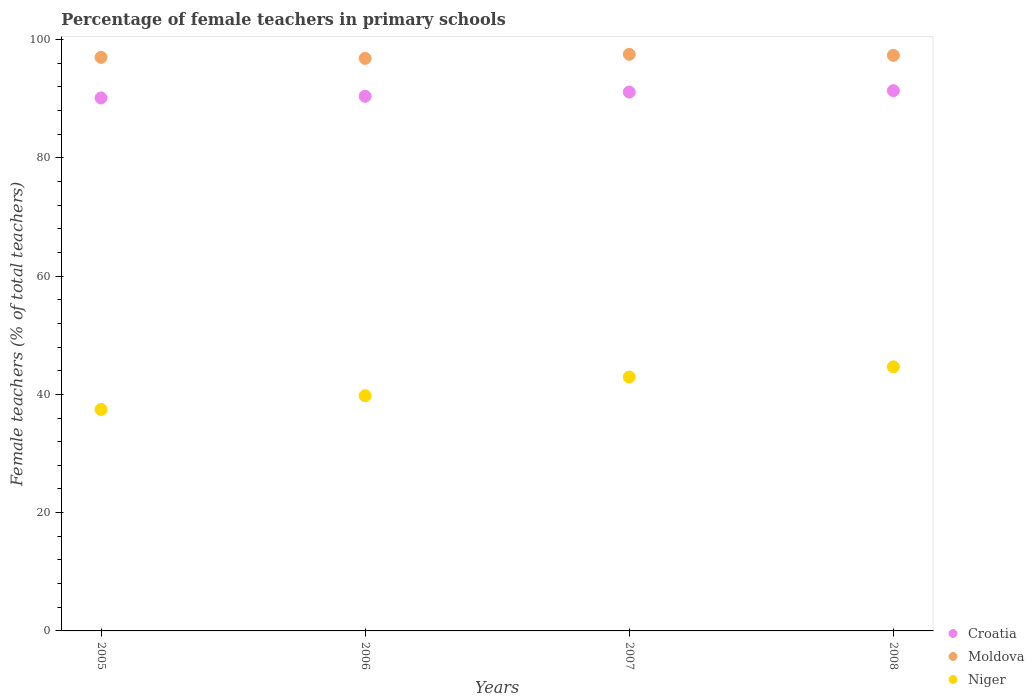Is the number of dotlines equal to the number of legend labels?
Your answer should be compact. Yes. What is the percentage of female teachers in Niger in 2007?
Ensure brevity in your answer.  42.93. Across all years, what is the maximum percentage of female teachers in Niger?
Provide a short and direct response. 44.66. Across all years, what is the minimum percentage of female teachers in Moldova?
Keep it short and to the point. 96.8. In which year was the percentage of female teachers in Moldova maximum?
Provide a succinct answer. 2007. What is the total percentage of female teachers in Niger in the graph?
Ensure brevity in your answer.  164.8. What is the difference between the percentage of female teachers in Croatia in 2006 and that in 2007?
Your answer should be very brief. -0.71. What is the difference between the percentage of female teachers in Moldova in 2006 and the percentage of female teachers in Croatia in 2005?
Your response must be concise. 6.68. What is the average percentage of female teachers in Croatia per year?
Provide a short and direct response. 90.74. In the year 2007, what is the difference between the percentage of female teachers in Moldova and percentage of female teachers in Croatia?
Provide a short and direct response. 6.38. What is the ratio of the percentage of female teachers in Niger in 2005 to that in 2006?
Give a very brief answer. 0.94. Is the percentage of female teachers in Croatia in 2005 less than that in 2006?
Ensure brevity in your answer.  Yes. What is the difference between the highest and the second highest percentage of female teachers in Niger?
Ensure brevity in your answer.  1.72. What is the difference between the highest and the lowest percentage of female teachers in Niger?
Your answer should be very brief. 7.22. In how many years, is the percentage of female teachers in Moldova greater than the average percentage of female teachers in Moldova taken over all years?
Provide a succinct answer. 2. Is the sum of the percentage of female teachers in Moldova in 2006 and 2008 greater than the maximum percentage of female teachers in Croatia across all years?
Your response must be concise. Yes. Is it the case that in every year, the sum of the percentage of female teachers in Moldova and percentage of female teachers in Niger  is greater than the percentage of female teachers in Croatia?
Ensure brevity in your answer.  Yes. Does the percentage of female teachers in Moldova monotonically increase over the years?
Ensure brevity in your answer.  No. Is the percentage of female teachers in Niger strictly greater than the percentage of female teachers in Moldova over the years?
Make the answer very short. No. How many dotlines are there?
Your response must be concise. 3. Does the graph contain any zero values?
Your answer should be very brief. No. Where does the legend appear in the graph?
Your answer should be compact. Bottom right. How are the legend labels stacked?
Your answer should be compact. Vertical. What is the title of the graph?
Offer a terse response. Percentage of female teachers in primary schools. What is the label or title of the Y-axis?
Keep it short and to the point. Female teachers (% of total teachers). What is the Female teachers (% of total teachers) of Croatia in 2005?
Make the answer very short. 90.12. What is the Female teachers (% of total teachers) in Moldova in 2005?
Offer a terse response. 96.98. What is the Female teachers (% of total teachers) in Niger in 2005?
Your answer should be compact. 37.44. What is the Female teachers (% of total teachers) in Croatia in 2006?
Provide a succinct answer. 90.4. What is the Female teachers (% of total teachers) of Moldova in 2006?
Make the answer very short. 96.8. What is the Female teachers (% of total teachers) of Niger in 2006?
Ensure brevity in your answer.  39.77. What is the Female teachers (% of total teachers) of Croatia in 2007?
Provide a succinct answer. 91.11. What is the Female teachers (% of total teachers) in Moldova in 2007?
Your answer should be very brief. 97.49. What is the Female teachers (% of total teachers) of Niger in 2007?
Keep it short and to the point. 42.93. What is the Female teachers (% of total teachers) in Croatia in 2008?
Your response must be concise. 91.35. What is the Female teachers (% of total teachers) of Moldova in 2008?
Offer a very short reply. 97.32. What is the Female teachers (% of total teachers) of Niger in 2008?
Provide a succinct answer. 44.66. Across all years, what is the maximum Female teachers (% of total teachers) in Croatia?
Give a very brief answer. 91.35. Across all years, what is the maximum Female teachers (% of total teachers) in Moldova?
Keep it short and to the point. 97.49. Across all years, what is the maximum Female teachers (% of total teachers) of Niger?
Your response must be concise. 44.66. Across all years, what is the minimum Female teachers (% of total teachers) of Croatia?
Make the answer very short. 90.12. Across all years, what is the minimum Female teachers (% of total teachers) in Moldova?
Offer a very short reply. 96.8. Across all years, what is the minimum Female teachers (% of total teachers) in Niger?
Offer a very short reply. 37.44. What is the total Female teachers (% of total teachers) in Croatia in the graph?
Offer a very short reply. 362.98. What is the total Female teachers (% of total teachers) in Moldova in the graph?
Make the answer very short. 388.59. What is the total Female teachers (% of total teachers) of Niger in the graph?
Your answer should be compact. 164.8. What is the difference between the Female teachers (% of total teachers) in Croatia in 2005 and that in 2006?
Your answer should be compact. -0.28. What is the difference between the Female teachers (% of total teachers) of Moldova in 2005 and that in 2006?
Provide a succinct answer. 0.18. What is the difference between the Female teachers (% of total teachers) of Niger in 2005 and that in 2006?
Offer a very short reply. -2.33. What is the difference between the Female teachers (% of total teachers) of Croatia in 2005 and that in 2007?
Ensure brevity in your answer.  -0.98. What is the difference between the Female teachers (% of total teachers) in Moldova in 2005 and that in 2007?
Make the answer very short. -0.51. What is the difference between the Female teachers (% of total teachers) in Niger in 2005 and that in 2007?
Ensure brevity in your answer.  -5.5. What is the difference between the Female teachers (% of total teachers) in Croatia in 2005 and that in 2008?
Your answer should be very brief. -1.22. What is the difference between the Female teachers (% of total teachers) of Moldova in 2005 and that in 2008?
Offer a very short reply. -0.35. What is the difference between the Female teachers (% of total teachers) of Niger in 2005 and that in 2008?
Keep it short and to the point. -7.22. What is the difference between the Female teachers (% of total teachers) of Croatia in 2006 and that in 2007?
Offer a very short reply. -0.71. What is the difference between the Female teachers (% of total teachers) in Moldova in 2006 and that in 2007?
Provide a succinct answer. -0.69. What is the difference between the Female teachers (% of total teachers) of Niger in 2006 and that in 2007?
Your response must be concise. -3.17. What is the difference between the Female teachers (% of total teachers) of Croatia in 2006 and that in 2008?
Your response must be concise. -0.95. What is the difference between the Female teachers (% of total teachers) in Moldova in 2006 and that in 2008?
Keep it short and to the point. -0.52. What is the difference between the Female teachers (% of total teachers) of Niger in 2006 and that in 2008?
Ensure brevity in your answer.  -4.89. What is the difference between the Female teachers (% of total teachers) of Croatia in 2007 and that in 2008?
Provide a succinct answer. -0.24. What is the difference between the Female teachers (% of total teachers) of Moldova in 2007 and that in 2008?
Ensure brevity in your answer.  0.17. What is the difference between the Female teachers (% of total teachers) in Niger in 2007 and that in 2008?
Keep it short and to the point. -1.72. What is the difference between the Female teachers (% of total teachers) in Croatia in 2005 and the Female teachers (% of total teachers) in Moldova in 2006?
Provide a succinct answer. -6.68. What is the difference between the Female teachers (% of total teachers) in Croatia in 2005 and the Female teachers (% of total teachers) in Niger in 2006?
Provide a succinct answer. 50.35. What is the difference between the Female teachers (% of total teachers) of Moldova in 2005 and the Female teachers (% of total teachers) of Niger in 2006?
Offer a terse response. 57.21. What is the difference between the Female teachers (% of total teachers) in Croatia in 2005 and the Female teachers (% of total teachers) in Moldova in 2007?
Your answer should be compact. -7.37. What is the difference between the Female teachers (% of total teachers) of Croatia in 2005 and the Female teachers (% of total teachers) of Niger in 2007?
Ensure brevity in your answer.  47.19. What is the difference between the Female teachers (% of total teachers) of Moldova in 2005 and the Female teachers (% of total teachers) of Niger in 2007?
Provide a succinct answer. 54.04. What is the difference between the Female teachers (% of total teachers) of Croatia in 2005 and the Female teachers (% of total teachers) of Moldova in 2008?
Offer a terse response. -7.2. What is the difference between the Female teachers (% of total teachers) in Croatia in 2005 and the Female teachers (% of total teachers) in Niger in 2008?
Your answer should be compact. 45.47. What is the difference between the Female teachers (% of total teachers) in Moldova in 2005 and the Female teachers (% of total teachers) in Niger in 2008?
Offer a terse response. 52.32. What is the difference between the Female teachers (% of total teachers) of Croatia in 2006 and the Female teachers (% of total teachers) of Moldova in 2007?
Give a very brief answer. -7.09. What is the difference between the Female teachers (% of total teachers) of Croatia in 2006 and the Female teachers (% of total teachers) of Niger in 2007?
Provide a succinct answer. 47.46. What is the difference between the Female teachers (% of total teachers) in Moldova in 2006 and the Female teachers (% of total teachers) in Niger in 2007?
Keep it short and to the point. 53.87. What is the difference between the Female teachers (% of total teachers) in Croatia in 2006 and the Female teachers (% of total teachers) in Moldova in 2008?
Offer a very short reply. -6.93. What is the difference between the Female teachers (% of total teachers) of Croatia in 2006 and the Female teachers (% of total teachers) of Niger in 2008?
Provide a short and direct response. 45.74. What is the difference between the Female teachers (% of total teachers) in Moldova in 2006 and the Female teachers (% of total teachers) in Niger in 2008?
Offer a terse response. 52.15. What is the difference between the Female teachers (% of total teachers) of Croatia in 2007 and the Female teachers (% of total teachers) of Moldova in 2008?
Offer a very short reply. -6.22. What is the difference between the Female teachers (% of total teachers) in Croatia in 2007 and the Female teachers (% of total teachers) in Niger in 2008?
Keep it short and to the point. 46.45. What is the difference between the Female teachers (% of total teachers) of Moldova in 2007 and the Female teachers (% of total teachers) of Niger in 2008?
Make the answer very short. 52.83. What is the average Female teachers (% of total teachers) of Croatia per year?
Give a very brief answer. 90.74. What is the average Female teachers (% of total teachers) in Moldova per year?
Ensure brevity in your answer.  97.15. What is the average Female teachers (% of total teachers) of Niger per year?
Ensure brevity in your answer.  41.2. In the year 2005, what is the difference between the Female teachers (% of total teachers) in Croatia and Female teachers (% of total teachers) in Moldova?
Provide a succinct answer. -6.86. In the year 2005, what is the difference between the Female teachers (% of total teachers) of Croatia and Female teachers (% of total teachers) of Niger?
Make the answer very short. 52.68. In the year 2005, what is the difference between the Female teachers (% of total teachers) of Moldova and Female teachers (% of total teachers) of Niger?
Keep it short and to the point. 59.54. In the year 2006, what is the difference between the Female teachers (% of total teachers) of Croatia and Female teachers (% of total teachers) of Moldova?
Keep it short and to the point. -6.4. In the year 2006, what is the difference between the Female teachers (% of total teachers) in Croatia and Female teachers (% of total teachers) in Niger?
Offer a very short reply. 50.63. In the year 2006, what is the difference between the Female teachers (% of total teachers) of Moldova and Female teachers (% of total teachers) of Niger?
Offer a very short reply. 57.03. In the year 2007, what is the difference between the Female teachers (% of total teachers) of Croatia and Female teachers (% of total teachers) of Moldova?
Ensure brevity in your answer.  -6.38. In the year 2007, what is the difference between the Female teachers (% of total teachers) in Croatia and Female teachers (% of total teachers) in Niger?
Your answer should be compact. 48.17. In the year 2007, what is the difference between the Female teachers (% of total teachers) in Moldova and Female teachers (% of total teachers) in Niger?
Offer a very short reply. 54.55. In the year 2008, what is the difference between the Female teachers (% of total teachers) of Croatia and Female teachers (% of total teachers) of Moldova?
Give a very brief answer. -5.98. In the year 2008, what is the difference between the Female teachers (% of total teachers) of Croatia and Female teachers (% of total teachers) of Niger?
Ensure brevity in your answer.  46.69. In the year 2008, what is the difference between the Female teachers (% of total teachers) of Moldova and Female teachers (% of total teachers) of Niger?
Offer a very short reply. 52.67. What is the ratio of the Female teachers (% of total teachers) of Croatia in 2005 to that in 2006?
Ensure brevity in your answer.  1. What is the ratio of the Female teachers (% of total teachers) of Niger in 2005 to that in 2006?
Your answer should be very brief. 0.94. What is the ratio of the Female teachers (% of total teachers) in Croatia in 2005 to that in 2007?
Provide a short and direct response. 0.99. What is the ratio of the Female teachers (% of total teachers) of Moldova in 2005 to that in 2007?
Your answer should be very brief. 0.99. What is the ratio of the Female teachers (% of total teachers) in Niger in 2005 to that in 2007?
Ensure brevity in your answer.  0.87. What is the ratio of the Female teachers (% of total teachers) of Croatia in 2005 to that in 2008?
Keep it short and to the point. 0.99. What is the ratio of the Female teachers (% of total teachers) of Niger in 2005 to that in 2008?
Your answer should be very brief. 0.84. What is the ratio of the Female teachers (% of total teachers) in Moldova in 2006 to that in 2007?
Make the answer very short. 0.99. What is the ratio of the Female teachers (% of total teachers) of Niger in 2006 to that in 2007?
Your answer should be compact. 0.93. What is the ratio of the Female teachers (% of total teachers) of Niger in 2006 to that in 2008?
Your response must be concise. 0.89. What is the ratio of the Female teachers (% of total teachers) of Croatia in 2007 to that in 2008?
Make the answer very short. 1. What is the ratio of the Female teachers (% of total teachers) in Moldova in 2007 to that in 2008?
Make the answer very short. 1. What is the ratio of the Female teachers (% of total teachers) of Niger in 2007 to that in 2008?
Your answer should be very brief. 0.96. What is the difference between the highest and the second highest Female teachers (% of total teachers) in Croatia?
Your response must be concise. 0.24. What is the difference between the highest and the second highest Female teachers (% of total teachers) in Moldova?
Provide a succinct answer. 0.17. What is the difference between the highest and the second highest Female teachers (% of total teachers) of Niger?
Ensure brevity in your answer.  1.72. What is the difference between the highest and the lowest Female teachers (% of total teachers) of Croatia?
Make the answer very short. 1.22. What is the difference between the highest and the lowest Female teachers (% of total teachers) of Moldova?
Provide a succinct answer. 0.69. What is the difference between the highest and the lowest Female teachers (% of total teachers) in Niger?
Your response must be concise. 7.22. 